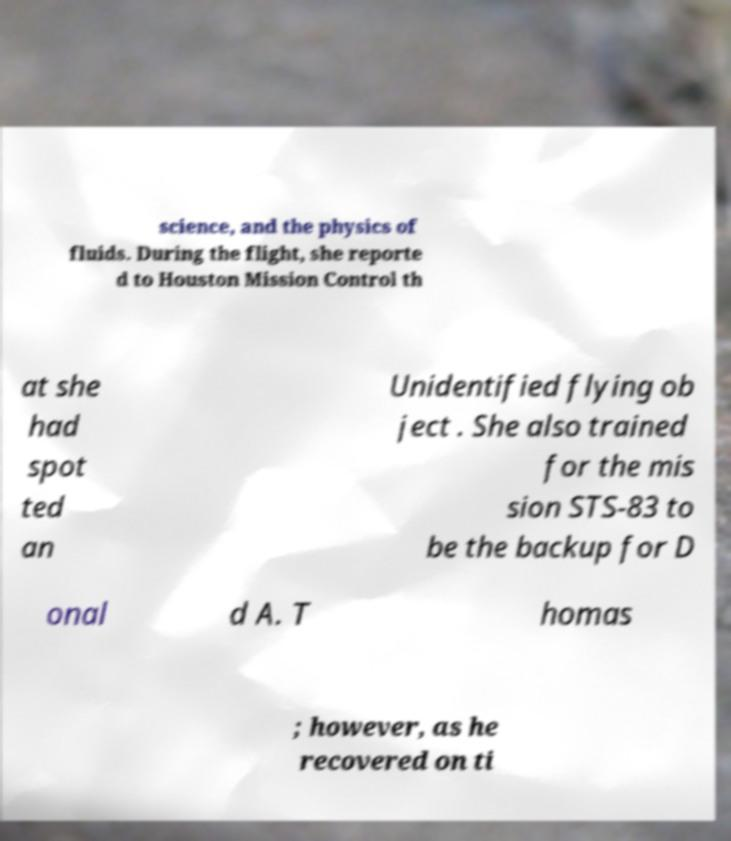Please read and relay the text visible in this image. What does it say? science, and the physics of fluids. During the flight, she reporte d to Houston Mission Control th at she had spot ted an Unidentified flying ob ject . She also trained for the mis sion STS-83 to be the backup for D onal d A. T homas ; however, as he recovered on ti 